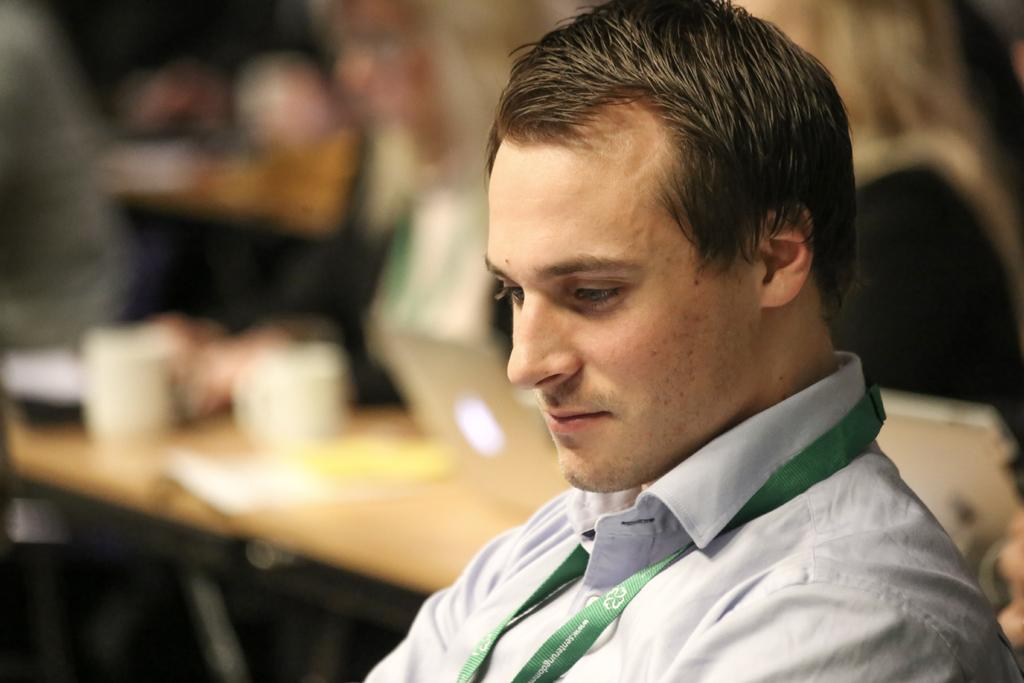What is present on the right side of the image? There is a man in the image. Can you describe the position of the man in the image? The man is on the right side of the image. What can be observed about the background area in the image? The background area is blurred. What type of giants can be seen in the image? There are no giants present in the image. What creature is interacting with the man in the image? There is no creature interacting with the man in the image. 